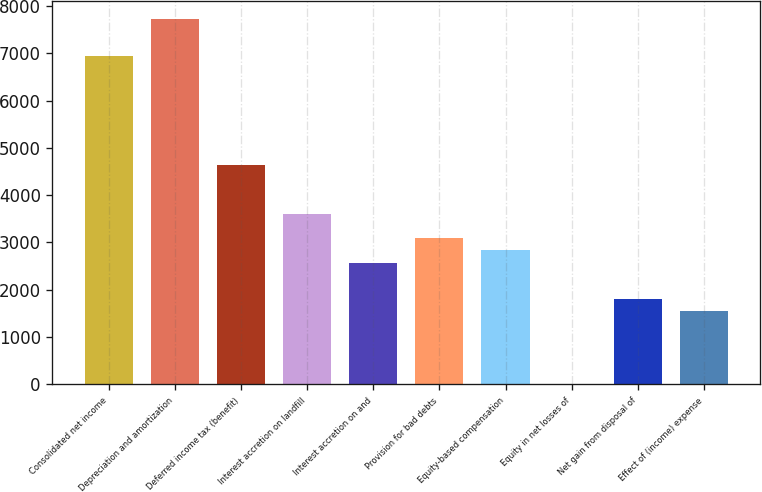Convert chart to OTSL. <chart><loc_0><loc_0><loc_500><loc_500><bar_chart><fcel>Consolidated net income<fcel>Depreciation and amortization<fcel>Deferred income tax (benefit)<fcel>Interest accretion on landfill<fcel>Interest accretion on and<fcel>Provision for bad debts<fcel>Equity-based compensation<fcel>Equity in net losses of<fcel>Net gain from disposal of<fcel>Effect of (income) expense<nl><fcel>6950.8<fcel>7723<fcel>4634.2<fcel>3604.6<fcel>2575<fcel>3089.8<fcel>2832.4<fcel>1<fcel>1802.8<fcel>1545.4<nl></chart> 